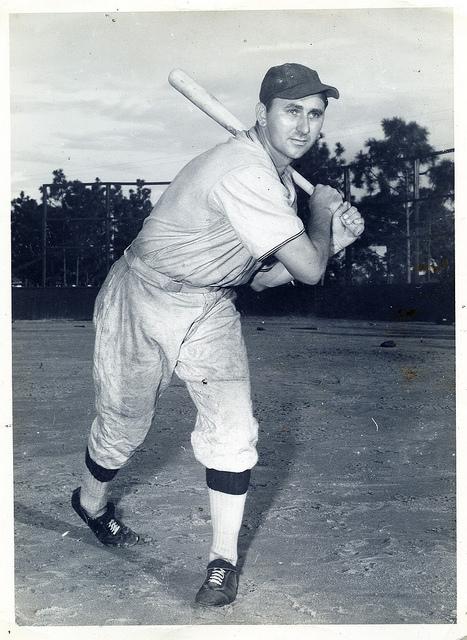What is the sport?
Concise answer only. Baseball. What is protecting the boy's eyes?
Answer briefly. Nothing. What sport is this person playing?
Keep it brief. Baseball. Is the person wearing a hat?
Quick response, please. Yes. Does the baseball player swing right or left handed?
Give a very brief answer. Left. 